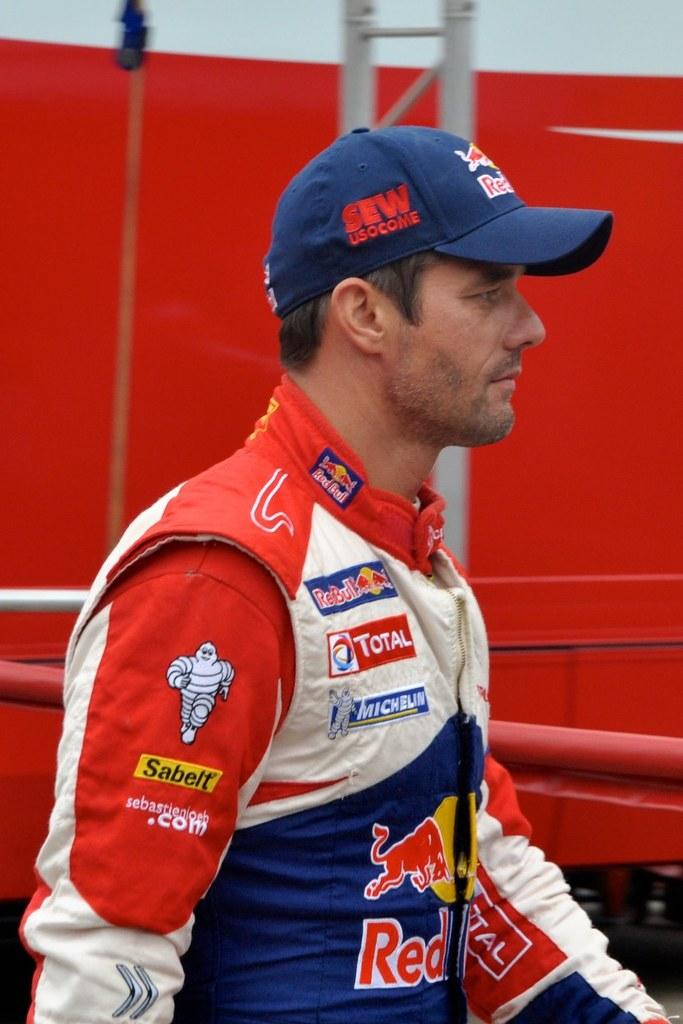Whos is the sponsor with the mascot?
Your answer should be very brief. Sabelt. 